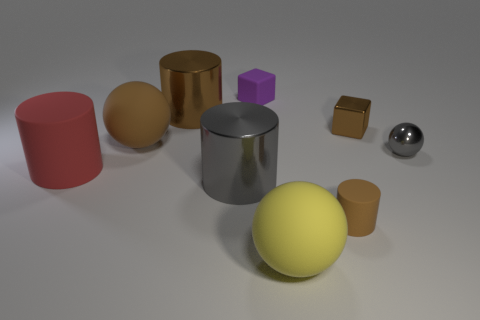How many big red matte things are behind the large brown shiny thing?
Make the answer very short. 0. There is a shiny thing in front of the metallic ball; is its shape the same as the large yellow matte thing?
Give a very brief answer. No. The big sphere that is right of the gray cylinder is what color?
Make the answer very short. Yellow. What is the shape of the purple object that is made of the same material as the tiny brown cylinder?
Your answer should be compact. Cube. Is there anything else of the same color as the matte block?
Provide a short and direct response. No. Is the number of rubber spheres in front of the gray shiny ball greater than the number of tiny cylinders that are left of the yellow rubber sphere?
Make the answer very short. Yes. How many green rubber cylinders are the same size as the yellow matte sphere?
Offer a very short reply. 0. Are there fewer small matte cubes in front of the gray metallic cylinder than brown cylinders that are behind the red rubber cylinder?
Keep it short and to the point. Yes. Are there any other rubber things of the same shape as the big yellow object?
Offer a terse response. Yes. Is the shape of the yellow object the same as the tiny gray thing?
Your answer should be very brief. Yes. 